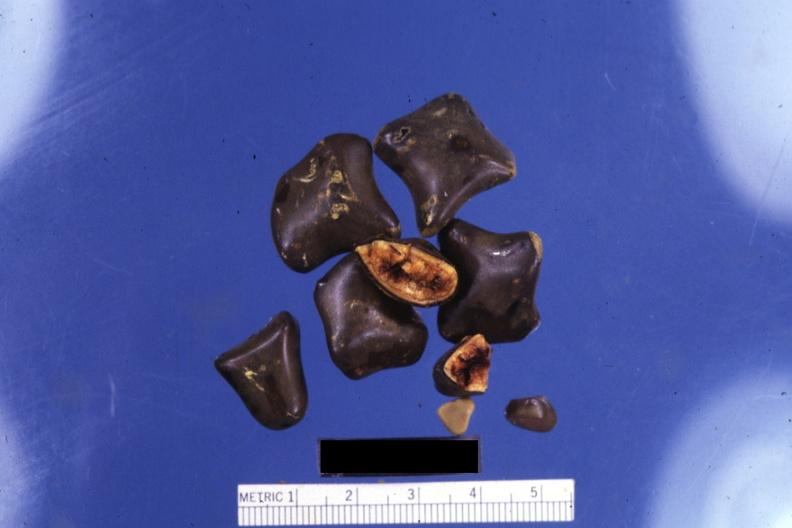what showing cut surfaces?
Answer the question using a single word or phrase. Close-up of faceted mixed stones with two 